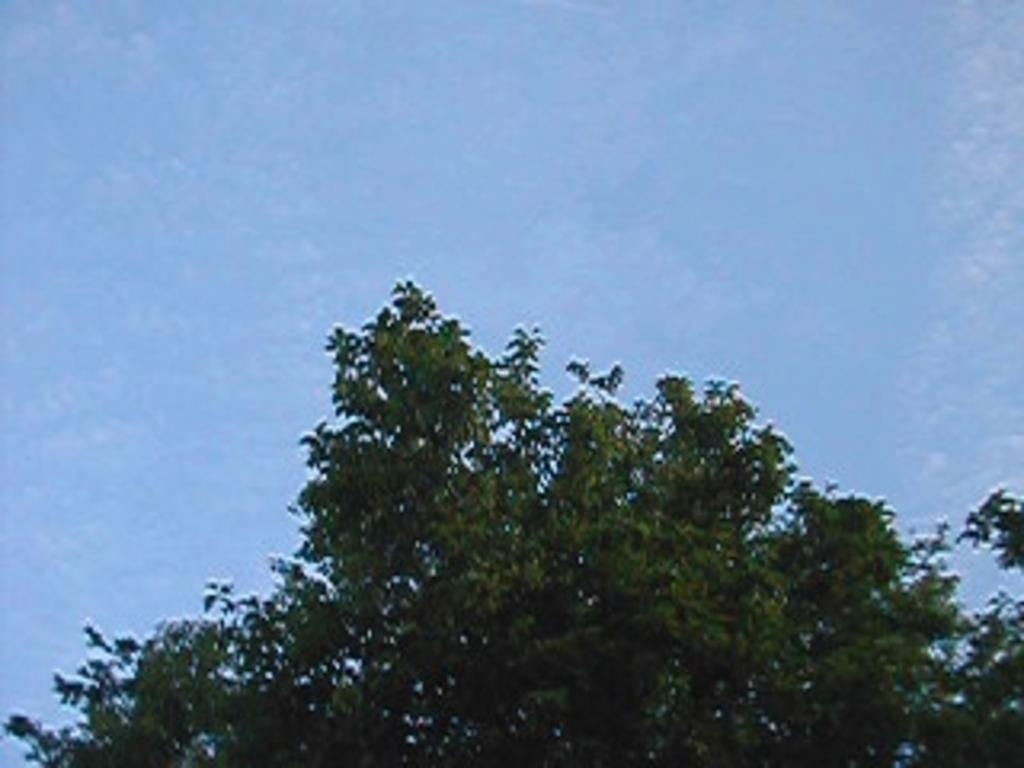What type of vegetation can be seen in the image? There are trees in the image. What color are the trees in the image? The trees are green in color. What can be seen in the background of the image? The sky is visible in the background of the image. What color is the sky in the image? The sky is blue in color. What type of copper vegetable can be seen growing on the trees in the image? There is no copper vegetable present in the image, and the trees are not growing any vegetables. 